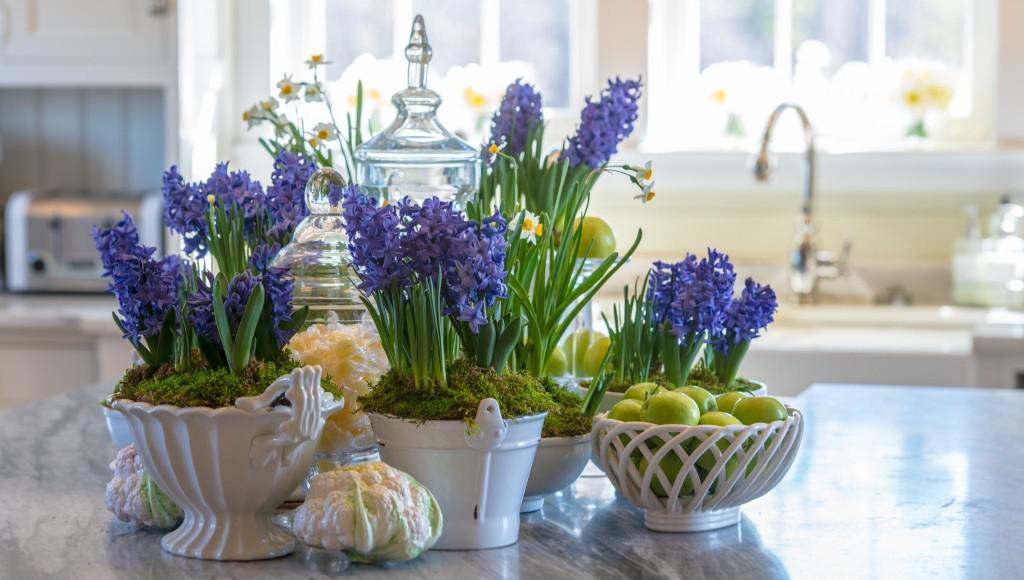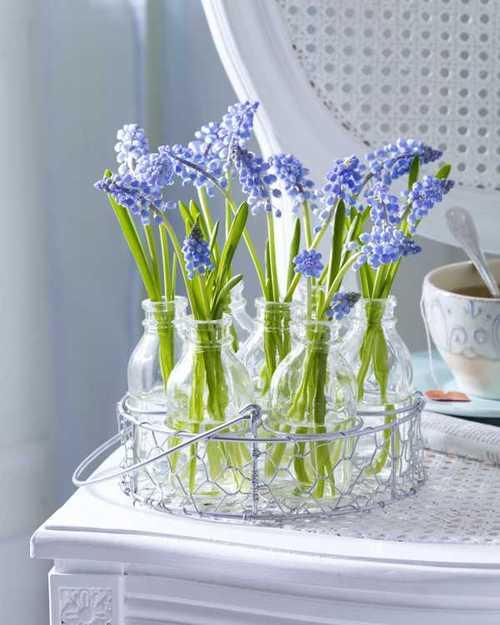The first image is the image on the left, the second image is the image on the right. Assess this claim about the two images: "Purple hyacinth and moss are growing in at least one white planter in the image on the left.". Correct or not? Answer yes or no. Yes. The first image is the image on the left, the second image is the image on the right. Analyze the images presented: Is the assertion "Right image features a variety of flowers, including roses." valid? Answer yes or no. No. 